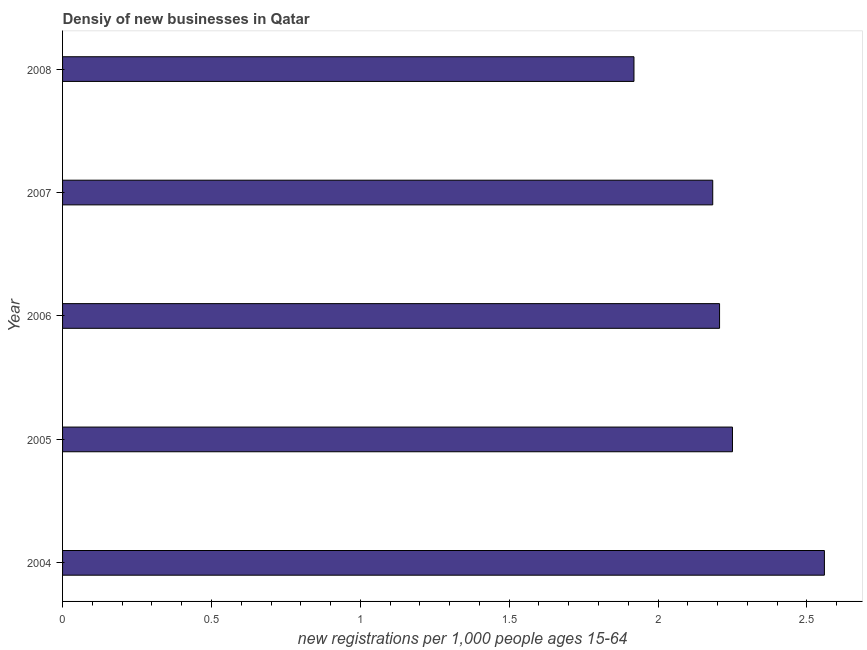Does the graph contain grids?
Make the answer very short. No. What is the title of the graph?
Provide a short and direct response. Densiy of new businesses in Qatar. What is the label or title of the X-axis?
Ensure brevity in your answer.  New registrations per 1,0 people ages 15-64. What is the label or title of the Y-axis?
Ensure brevity in your answer.  Year. What is the density of new business in 2007?
Provide a succinct answer. 2.18. Across all years, what is the maximum density of new business?
Give a very brief answer. 2.56. Across all years, what is the minimum density of new business?
Keep it short and to the point. 1.92. In which year was the density of new business maximum?
Your answer should be compact. 2004. In which year was the density of new business minimum?
Your answer should be very brief. 2008. What is the sum of the density of new business?
Give a very brief answer. 11.12. What is the difference between the density of new business in 2006 and 2008?
Ensure brevity in your answer.  0.29. What is the average density of new business per year?
Keep it short and to the point. 2.22. What is the median density of new business?
Provide a succinct answer. 2.21. In how many years, is the density of new business greater than 2.3 ?
Offer a very short reply. 1. What is the ratio of the density of new business in 2005 to that in 2008?
Provide a short and direct response. 1.17. Is the density of new business in 2005 less than that in 2008?
Make the answer very short. No. What is the difference between the highest and the second highest density of new business?
Ensure brevity in your answer.  0.31. What is the difference between the highest and the lowest density of new business?
Your response must be concise. 0.64. Are all the bars in the graph horizontal?
Your response must be concise. Yes. How many years are there in the graph?
Provide a succinct answer. 5. What is the difference between two consecutive major ticks on the X-axis?
Your response must be concise. 0.5. What is the new registrations per 1,000 people ages 15-64 of 2004?
Provide a succinct answer. 2.56. What is the new registrations per 1,000 people ages 15-64 in 2005?
Your response must be concise. 2.25. What is the new registrations per 1,000 people ages 15-64 of 2006?
Offer a terse response. 2.21. What is the new registrations per 1,000 people ages 15-64 in 2007?
Offer a very short reply. 2.18. What is the new registrations per 1,000 people ages 15-64 in 2008?
Your response must be concise. 1.92. What is the difference between the new registrations per 1,000 people ages 15-64 in 2004 and 2005?
Provide a succinct answer. 0.31. What is the difference between the new registrations per 1,000 people ages 15-64 in 2004 and 2006?
Provide a short and direct response. 0.35. What is the difference between the new registrations per 1,000 people ages 15-64 in 2004 and 2007?
Your answer should be compact. 0.38. What is the difference between the new registrations per 1,000 people ages 15-64 in 2004 and 2008?
Make the answer very short. 0.64. What is the difference between the new registrations per 1,000 people ages 15-64 in 2005 and 2006?
Your answer should be compact. 0.04. What is the difference between the new registrations per 1,000 people ages 15-64 in 2005 and 2007?
Your answer should be very brief. 0.07. What is the difference between the new registrations per 1,000 people ages 15-64 in 2005 and 2008?
Provide a short and direct response. 0.33. What is the difference between the new registrations per 1,000 people ages 15-64 in 2006 and 2007?
Ensure brevity in your answer.  0.02. What is the difference between the new registrations per 1,000 people ages 15-64 in 2006 and 2008?
Your response must be concise. 0.29. What is the difference between the new registrations per 1,000 people ages 15-64 in 2007 and 2008?
Offer a terse response. 0.26. What is the ratio of the new registrations per 1,000 people ages 15-64 in 2004 to that in 2005?
Keep it short and to the point. 1.14. What is the ratio of the new registrations per 1,000 people ages 15-64 in 2004 to that in 2006?
Your answer should be compact. 1.16. What is the ratio of the new registrations per 1,000 people ages 15-64 in 2004 to that in 2007?
Offer a terse response. 1.17. What is the ratio of the new registrations per 1,000 people ages 15-64 in 2004 to that in 2008?
Your answer should be compact. 1.33. What is the ratio of the new registrations per 1,000 people ages 15-64 in 2005 to that in 2006?
Your answer should be compact. 1.02. What is the ratio of the new registrations per 1,000 people ages 15-64 in 2005 to that in 2008?
Offer a terse response. 1.17. What is the ratio of the new registrations per 1,000 people ages 15-64 in 2006 to that in 2008?
Offer a terse response. 1.15. What is the ratio of the new registrations per 1,000 people ages 15-64 in 2007 to that in 2008?
Keep it short and to the point. 1.14. 